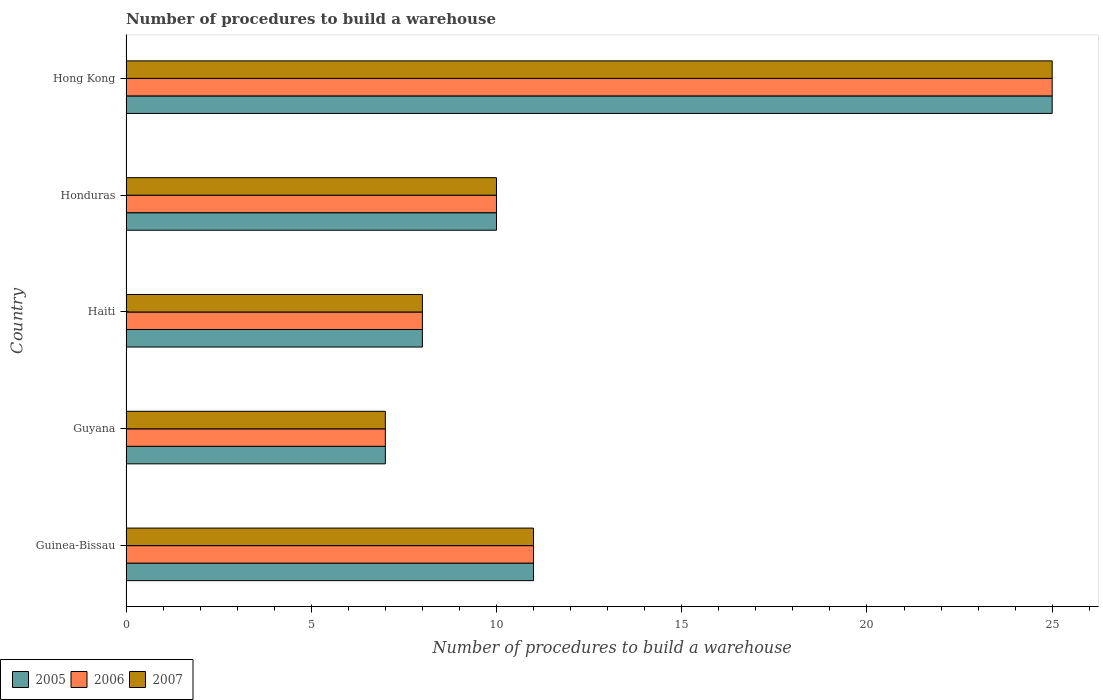How many groups of bars are there?
Make the answer very short. 5. How many bars are there on the 2nd tick from the top?
Keep it short and to the point. 3. How many bars are there on the 3rd tick from the bottom?
Provide a succinct answer. 3. What is the label of the 1st group of bars from the top?
Ensure brevity in your answer.  Hong Kong. In how many cases, is the number of bars for a given country not equal to the number of legend labels?
Your answer should be compact. 0. In which country was the number of procedures to build a warehouse in in 2006 maximum?
Keep it short and to the point. Hong Kong. In which country was the number of procedures to build a warehouse in in 2006 minimum?
Your response must be concise. Guyana. What is the total number of procedures to build a warehouse in in 2006 in the graph?
Give a very brief answer. 61. What is the ratio of the number of procedures to build a warehouse in in 2007 in Haiti to that in Hong Kong?
Give a very brief answer. 0.32. Is the number of procedures to build a warehouse in in 2006 in Guyana less than that in Hong Kong?
Give a very brief answer. Yes. What is the difference between the highest and the lowest number of procedures to build a warehouse in in 2006?
Your answer should be compact. 18. In how many countries, is the number of procedures to build a warehouse in in 2005 greater than the average number of procedures to build a warehouse in in 2005 taken over all countries?
Keep it short and to the point. 1. How many bars are there?
Your response must be concise. 15. How many countries are there in the graph?
Your response must be concise. 5. Does the graph contain any zero values?
Provide a succinct answer. No. Where does the legend appear in the graph?
Your response must be concise. Bottom left. How many legend labels are there?
Offer a very short reply. 3. What is the title of the graph?
Your answer should be compact. Number of procedures to build a warehouse. What is the label or title of the X-axis?
Offer a terse response. Number of procedures to build a warehouse. What is the label or title of the Y-axis?
Offer a terse response. Country. What is the Number of procedures to build a warehouse of 2005 in Guinea-Bissau?
Provide a short and direct response. 11. What is the Number of procedures to build a warehouse in 2005 in Guyana?
Your answer should be compact. 7. What is the Number of procedures to build a warehouse of 2006 in Haiti?
Make the answer very short. 8. What is the Number of procedures to build a warehouse in 2007 in Honduras?
Ensure brevity in your answer.  10. What is the Number of procedures to build a warehouse of 2007 in Hong Kong?
Your answer should be compact. 25. Across all countries, what is the maximum Number of procedures to build a warehouse of 2005?
Provide a short and direct response. 25. Across all countries, what is the minimum Number of procedures to build a warehouse in 2005?
Your answer should be compact. 7. Across all countries, what is the minimum Number of procedures to build a warehouse of 2006?
Your response must be concise. 7. What is the total Number of procedures to build a warehouse in 2006 in the graph?
Your answer should be compact. 61. What is the difference between the Number of procedures to build a warehouse in 2005 in Guinea-Bissau and that in Guyana?
Offer a very short reply. 4. What is the difference between the Number of procedures to build a warehouse of 2006 in Guinea-Bissau and that in Guyana?
Give a very brief answer. 4. What is the difference between the Number of procedures to build a warehouse in 2007 in Guinea-Bissau and that in Guyana?
Offer a terse response. 4. What is the difference between the Number of procedures to build a warehouse in 2005 in Guinea-Bissau and that in Haiti?
Make the answer very short. 3. What is the difference between the Number of procedures to build a warehouse in 2006 in Guinea-Bissau and that in Haiti?
Provide a succinct answer. 3. What is the difference between the Number of procedures to build a warehouse of 2007 in Guinea-Bissau and that in Haiti?
Your answer should be compact. 3. What is the difference between the Number of procedures to build a warehouse of 2007 in Guinea-Bissau and that in Honduras?
Your answer should be compact. 1. What is the difference between the Number of procedures to build a warehouse of 2005 in Guinea-Bissau and that in Hong Kong?
Provide a succinct answer. -14. What is the difference between the Number of procedures to build a warehouse of 2007 in Guinea-Bissau and that in Hong Kong?
Provide a succinct answer. -14. What is the difference between the Number of procedures to build a warehouse in 2006 in Guyana and that in Haiti?
Make the answer very short. -1. What is the difference between the Number of procedures to build a warehouse of 2005 in Guyana and that in Honduras?
Ensure brevity in your answer.  -3. What is the difference between the Number of procedures to build a warehouse in 2006 in Guyana and that in Honduras?
Give a very brief answer. -3. What is the difference between the Number of procedures to build a warehouse of 2006 in Guyana and that in Hong Kong?
Offer a terse response. -18. What is the difference between the Number of procedures to build a warehouse of 2005 in Haiti and that in Hong Kong?
Offer a terse response. -17. What is the difference between the Number of procedures to build a warehouse of 2006 in Haiti and that in Hong Kong?
Offer a very short reply. -17. What is the difference between the Number of procedures to build a warehouse of 2007 in Honduras and that in Hong Kong?
Give a very brief answer. -15. What is the difference between the Number of procedures to build a warehouse of 2006 in Guinea-Bissau and the Number of procedures to build a warehouse of 2007 in Guyana?
Make the answer very short. 4. What is the difference between the Number of procedures to build a warehouse of 2005 in Guinea-Bissau and the Number of procedures to build a warehouse of 2006 in Haiti?
Ensure brevity in your answer.  3. What is the difference between the Number of procedures to build a warehouse in 2005 in Guinea-Bissau and the Number of procedures to build a warehouse in 2007 in Haiti?
Make the answer very short. 3. What is the difference between the Number of procedures to build a warehouse of 2005 in Guinea-Bissau and the Number of procedures to build a warehouse of 2006 in Honduras?
Your answer should be very brief. 1. What is the difference between the Number of procedures to build a warehouse in 2006 in Guinea-Bissau and the Number of procedures to build a warehouse in 2007 in Honduras?
Give a very brief answer. 1. What is the difference between the Number of procedures to build a warehouse in 2006 in Guyana and the Number of procedures to build a warehouse in 2007 in Haiti?
Offer a terse response. -1. What is the difference between the Number of procedures to build a warehouse in 2005 in Guyana and the Number of procedures to build a warehouse in 2007 in Honduras?
Offer a very short reply. -3. What is the difference between the Number of procedures to build a warehouse of 2006 in Guyana and the Number of procedures to build a warehouse of 2007 in Honduras?
Keep it short and to the point. -3. What is the difference between the Number of procedures to build a warehouse in 2005 in Guyana and the Number of procedures to build a warehouse in 2007 in Hong Kong?
Ensure brevity in your answer.  -18. What is the difference between the Number of procedures to build a warehouse in 2006 in Guyana and the Number of procedures to build a warehouse in 2007 in Hong Kong?
Provide a succinct answer. -18. What is the difference between the Number of procedures to build a warehouse of 2006 in Honduras and the Number of procedures to build a warehouse of 2007 in Hong Kong?
Your answer should be compact. -15. What is the average Number of procedures to build a warehouse in 2007 per country?
Provide a succinct answer. 12.2. What is the difference between the Number of procedures to build a warehouse of 2005 and Number of procedures to build a warehouse of 2006 in Guinea-Bissau?
Your answer should be compact. 0. What is the difference between the Number of procedures to build a warehouse of 2005 and Number of procedures to build a warehouse of 2007 in Guinea-Bissau?
Provide a succinct answer. 0. What is the difference between the Number of procedures to build a warehouse in 2006 and Number of procedures to build a warehouse in 2007 in Guinea-Bissau?
Ensure brevity in your answer.  0. What is the difference between the Number of procedures to build a warehouse in 2005 and Number of procedures to build a warehouse in 2006 in Guyana?
Keep it short and to the point. 0. What is the difference between the Number of procedures to build a warehouse in 2006 and Number of procedures to build a warehouse in 2007 in Guyana?
Your answer should be compact. 0. What is the difference between the Number of procedures to build a warehouse in 2005 and Number of procedures to build a warehouse in 2006 in Haiti?
Ensure brevity in your answer.  0. What is the difference between the Number of procedures to build a warehouse in 2006 and Number of procedures to build a warehouse in 2007 in Haiti?
Offer a terse response. 0. What is the difference between the Number of procedures to build a warehouse of 2005 and Number of procedures to build a warehouse of 2007 in Hong Kong?
Your response must be concise. 0. What is the difference between the Number of procedures to build a warehouse in 2006 and Number of procedures to build a warehouse in 2007 in Hong Kong?
Ensure brevity in your answer.  0. What is the ratio of the Number of procedures to build a warehouse in 2005 in Guinea-Bissau to that in Guyana?
Offer a terse response. 1.57. What is the ratio of the Number of procedures to build a warehouse in 2006 in Guinea-Bissau to that in Guyana?
Offer a terse response. 1.57. What is the ratio of the Number of procedures to build a warehouse in 2007 in Guinea-Bissau to that in Guyana?
Keep it short and to the point. 1.57. What is the ratio of the Number of procedures to build a warehouse in 2005 in Guinea-Bissau to that in Haiti?
Make the answer very short. 1.38. What is the ratio of the Number of procedures to build a warehouse in 2006 in Guinea-Bissau to that in Haiti?
Your answer should be very brief. 1.38. What is the ratio of the Number of procedures to build a warehouse of 2007 in Guinea-Bissau to that in Haiti?
Your answer should be very brief. 1.38. What is the ratio of the Number of procedures to build a warehouse in 2006 in Guinea-Bissau to that in Honduras?
Give a very brief answer. 1.1. What is the ratio of the Number of procedures to build a warehouse of 2005 in Guinea-Bissau to that in Hong Kong?
Provide a short and direct response. 0.44. What is the ratio of the Number of procedures to build a warehouse in 2006 in Guinea-Bissau to that in Hong Kong?
Ensure brevity in your answer.  0.44. What is the ratio of the Number of procedures to build a warehouse of 2007 in Guinea-Bissau to that in Hong Kong?
Give a very brief answer. 0.44. What is the ratio of the Number of procedures to build a warehouse of 2005 in Guyana to that in Haiti?
Keep it short and to the point. 0.88. What is the ratio of the Number of procedures to build a warehouse in 2006 in Guyana to that in Haiti?
Give a very brief answer. 0.88. What is the ratio of the Number of procedures to build a warehouse in 2007 in Guyana to that in Haiti?
Make the answer very short. 0.88. What is the ratio of the Number of procedures to build a warehouse in 2006 in Guyana to that in Honduras?
Provide a succinct answer. 0.7. What is the ratio of the Number of procedures to build a warehouse of 2007 in Guyana to that in Honduras?
Your response must be concise. 0.7. What is the ratio of the Number of procedures to build a warehouse of 2005 in Guyana to that in Hong Kong?
Keep it short and to the point. 0.28. What is the ratio of the Number of procedures to build a warehouse of 2006 in Guyana to that in Hong Kong?
Offer a terse response. 0.28. What is the ratio of the Number of procedures to build a warehouse in 2007 in Guyana to that in Hong Kong?
Your response must be concise. 0.28. What is the ratio of the Number of procedures to build a warehouse in 2005 in Haiti to that in Honduras?
Your answer should be very brief. 0.8. What is the ratio of the Number of procedures to build a warehouse of 2006 in Haiti to that in Honduras?
Your answer should be very brief. 0.8. What is the ratio of the Number of procedures to build a warehouse of 2007 in Haiti to that in Honduras?
Your answer should be compact. 0.8. What is the ratio of the Number of procedures to build a warehouse in 2005 in Haiti to that in Hong Kong?
Provide a short and direct response. 0.32. What is the ratio of the Number of procedures to build a warehouse of 2006 in Haiti to that in Hong Kong?
Your answer should be very brief. 0.32. What is the ratio of the Number of procedures to build a warehouse in 2007 in Haiti to that in Hong Kong?
Make the answer very short. 0.32. What is the ratio of the Number of procedures to build a warehouse in 2006 in Honduras to that in Hong Kong?
Make the answer very short. 0.4. What is the ratio of the Number of procedures to build a warehouse of 2007 in Honduras to that in Hong Kong?
Give a very brief answer. 0.4. What is the difference between the highest and the second highest Number of procedures to build a warehouse in 2005?
Your answer should be very brief. 14. What is the difference between the highest and the second highest Number of procedures to build a warehouse in 2006?
Offer a very short reply. 14. What is the difference between the highest and the lowest Number of procedures to build a warehouse in 2006?
Offer a terse response. 18. What is the difference between the highest and the lowest Number of procedures to build a warehouse of 2007?
Offer a terse response. 18. 